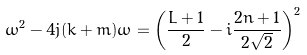<formula> <loc_0><loc_0><loc_500><loc_500>\omega ^ { 2 } - 4 j ( k + m ) \omega = \left ( \frac { L + 1 } { 2 } - i \frac { 2 n + 1 } { 2 \sqrt { 2 } } \right ) ^ { 2 }</formula> 